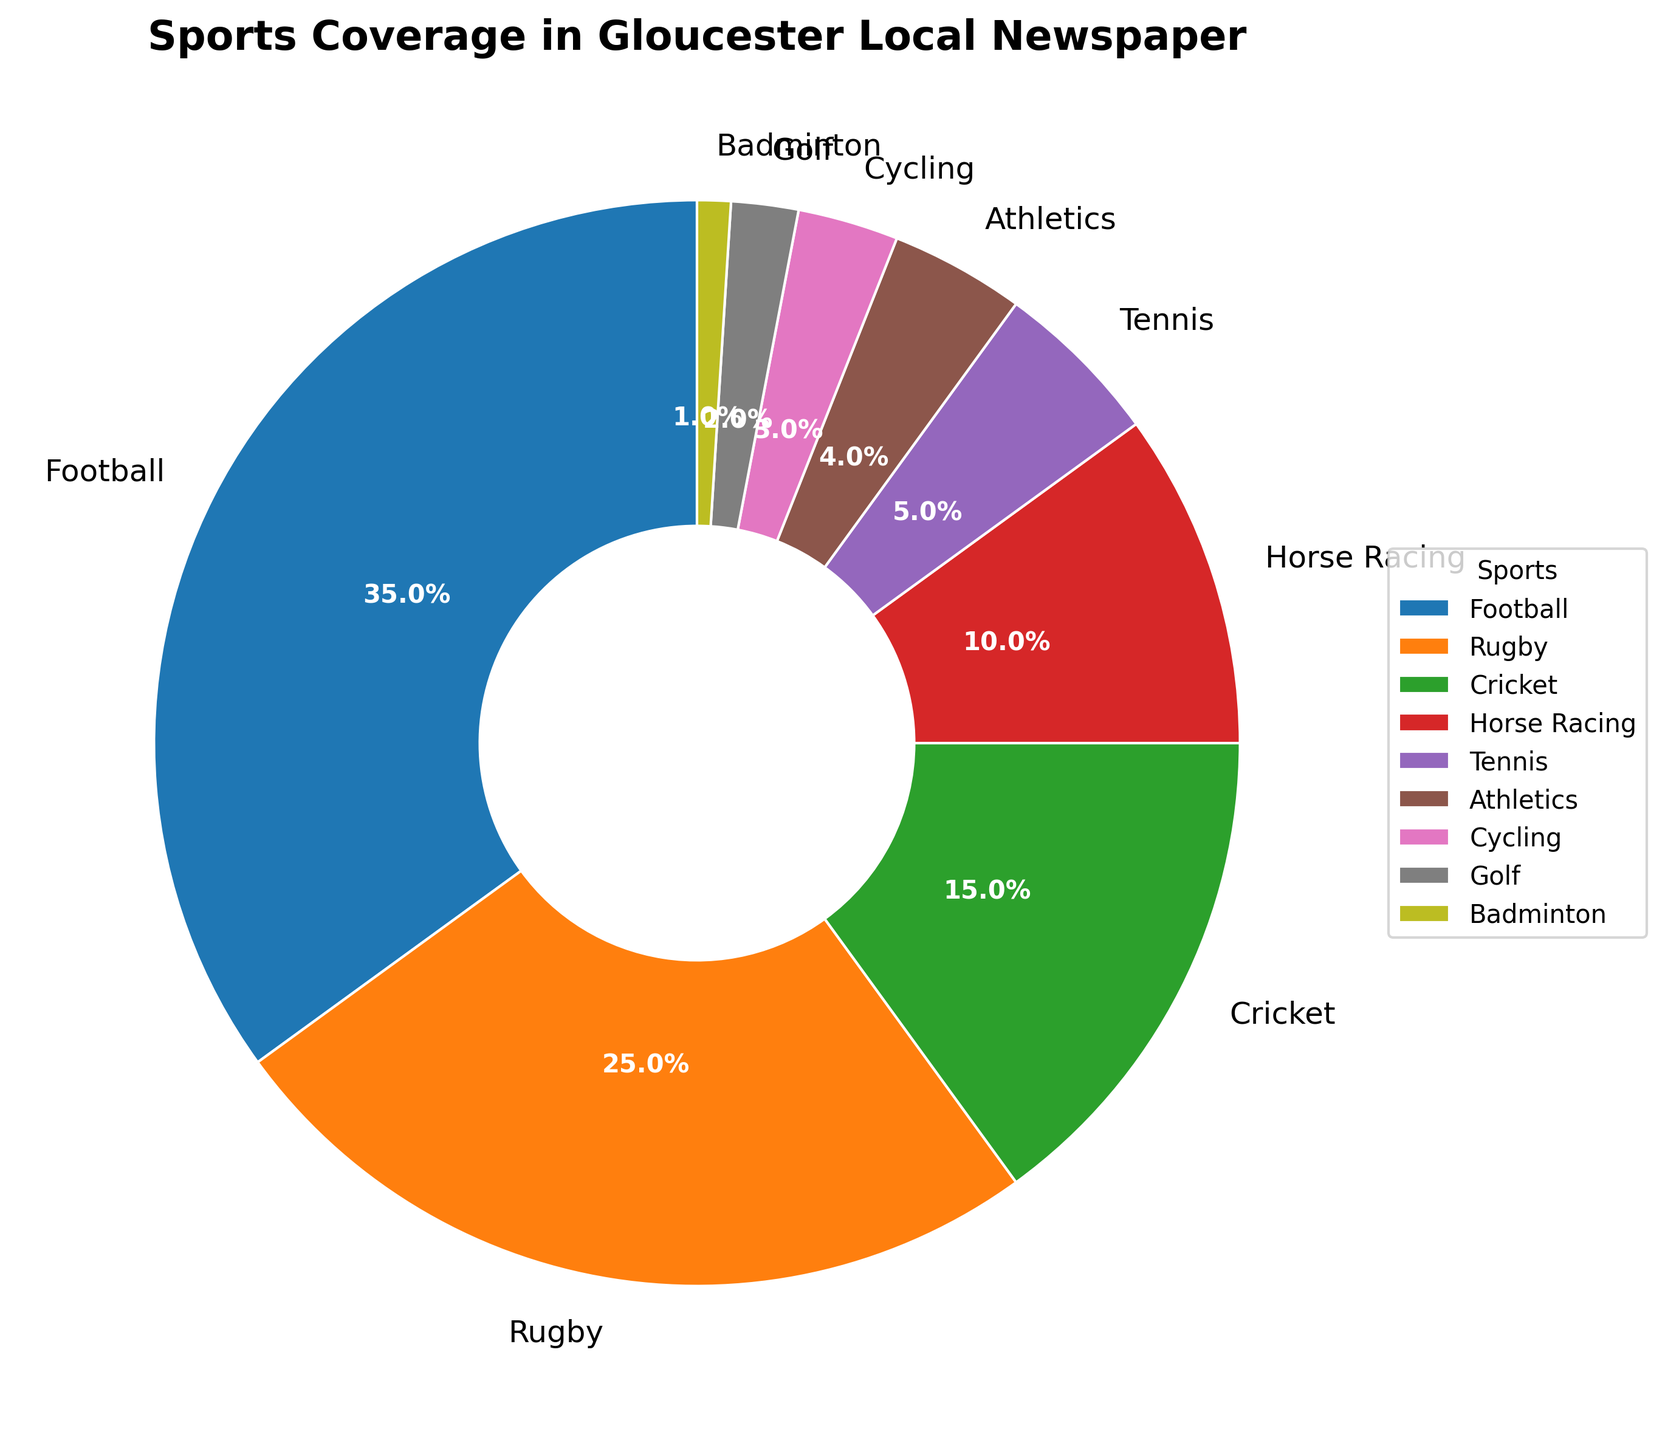What percentage of the sports coverage is dedicated to Rugby and Cricket combined? To find the combined coverage percentage for Rugby and Cricket, add the percentages for Rugby (25%) and Cricket (15%). The combined percentage is 25% + 15% = 40%.
Answer: 40% Which sport receives the least coverage? To find the sport with the least coverage, look for the smallest percentage in the pie chart, which is Badminton with 1%.
Answer: Badminton Does Horse Racing receive more coverage than Tennis? To compare the coverage of Horse Racing and Tennis, check their respective percentages in the pie chart. Horse Racing has 10% while Tennis has 5%. Therefore, Horse Racing receives more coverage.
Answer: Yes What is the difference in coverage between Football and Athletics? To find the difference in coverage between Football and Athletics, subtract the percentage of Athletics (4%) from Football (35%). The difference is 35% - 4% = 31%.
Answer: 31% Which sports have a combined coverage of less than 10%? To find sports with less than 10% coverage, identify percentages below 10%: Tennis (5%), Athletics (4%), Cycling (3%), Golf (2%), and Badminton (1%).
Answer: Tennis, Athletics, Cycling, Golf, and Badminton How much more coverage does Rugby get compared to Cycling? To find how much more coverage Rugby receives compared to Cycling, subtract the percentage of Cycling (3%) from Rugby (25%). The difference is 25% - 3% = 22%.
Answer: 22% Which sport has the second highest coverage, and what is its percentage? To find the second highest coverage, identify the percentages and rank them. The highest is Football (35%), and the second highest is Rugby with 25%.
Answer: Rugby, 25% What is the average coverage percentage for Cricket, Tennis, and Cycling? To find the average percentage, add the values for Cricket (15%), Tennis (5%), and Cycling (3%) and divide by the number of sports. The sum is 15% + 5% + 3% = 23%, and the average is 23% / 3 ≈ 7.67%.
Answer: 7.67% Does Golf and Badminton together have more coverage than Athletics? To compare Golf and Badminton combined coverage with Athletics, add Golf's 2% and Badminton's 1%. The combined coverage is 2% + 1% = 3%, which is less than Athletics' 4%.
Answer: No Which sports each have less than 5% coverage? Identify the sports with percentages below 5%: Athletics (4%), Cycling (3%), Golf (2%), Badminton (1%).
Answer: Athletics, Cycling, Golf, and Badminton 